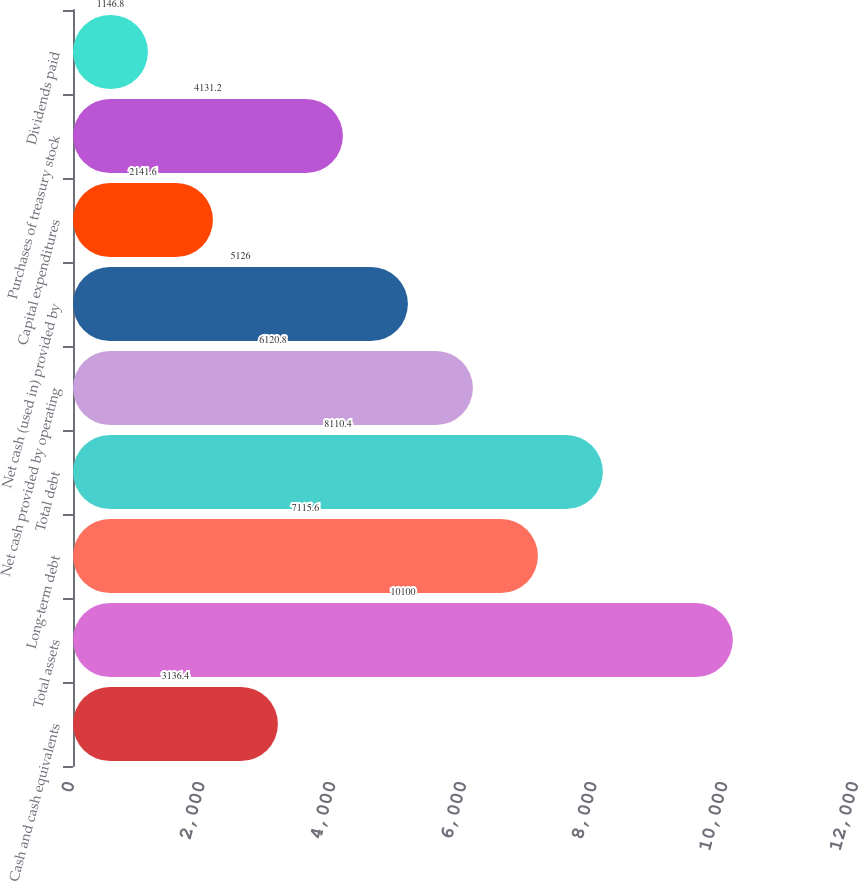Convert chart to OTSL. <chart><loc_0><loc_0><loc_500><loc_500><bar_chart><fcel>Cash and cash equivalents<fcel>Total assets<fcel>Long-term debt<fcel>Total debt<fcel>Net cash provided by operating<fcel>Net cash (used in) provided by<fcel>Capital expenditures<fcel>Purchases of treasury stock<fcel>Dividends paid<nl><fcel>3136.4<fcel>10100<fcel>7115.6<fcel>8110.4<fcel>6120.8<fcel>5126<fcel>2141.6<fcel>4131.2<fcel>1146.8<nl></chart> 